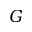<formula> <loc_0><loc_0><loc_500><loc_500>G</formula> 